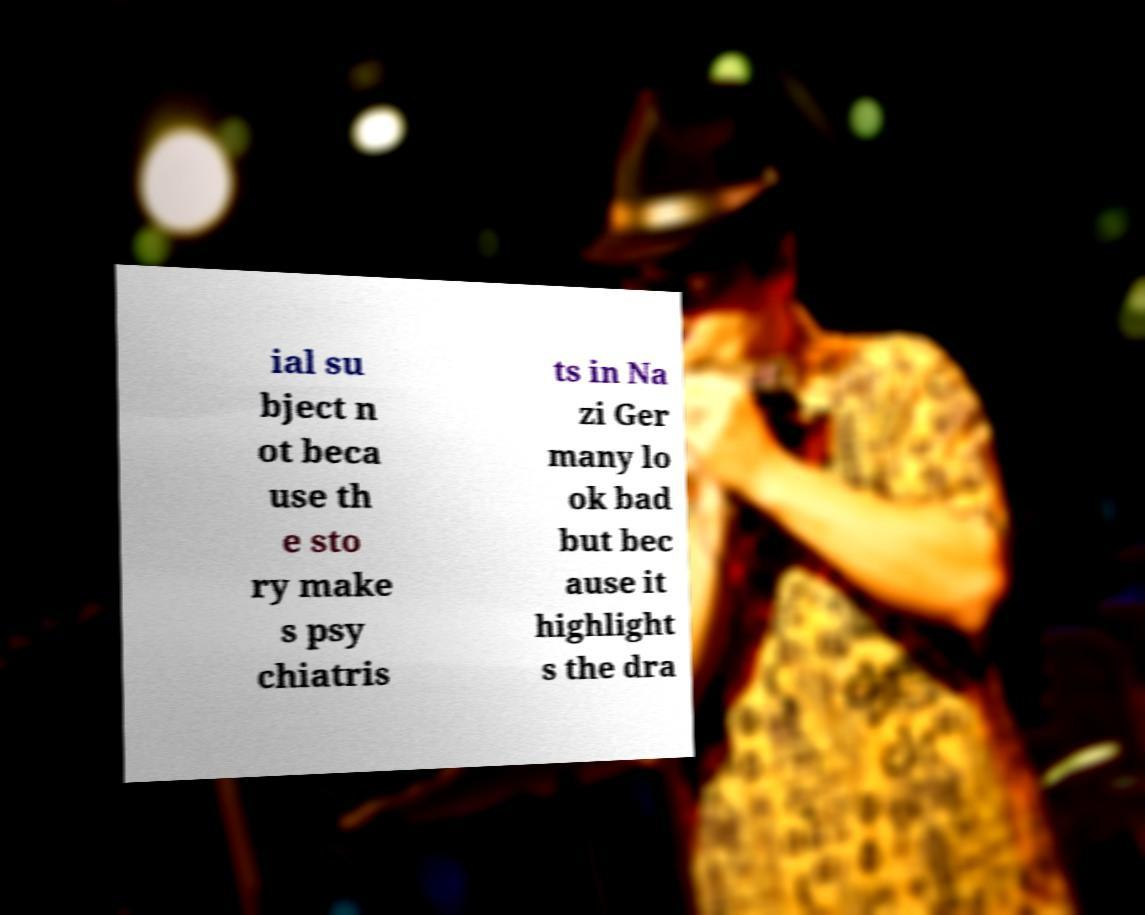For documentation purposes, I need the text within this image transcribed. Could you provide that? ial su bject n ot beca use th e sto ry make s psy chiatris ts in Na zi Ger many lo ok bad but bec ause it highlight s the dra 